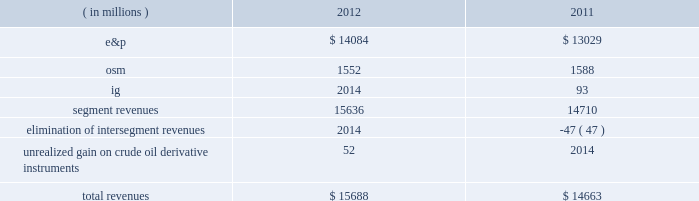Key operating and financial activities significant operating and financial activities during 2012 include : 2022 net proved reserve additions for the e&p and osm segments combined of 389 mmboe , for a 226 percent reserve replacement 2022 increased proved liquid hydrocarbon and synthetic crude oil reserves by 316 mmbbls , for a reserve replacement of 268 percent for these commodities 2022 recorded more than 95 percent average operational availability for operated e&p assets 2022 increased e&p net sales volumes , excluding libya , by 8 percent 2022 eagle ford shale average net sales volumes of 65 mboed for december 2012 , a fourfold increase over december 2011 2022 bakken shale average net sales volumes of 29 mboed , a 71 percent increase over last year 2022 resumed sales from libya and reached pre-conflict production levels 2022 international liquid hydrocarbon sales volumes , for which average realizations have exceeded wti , were 62 percent of net e&p liquid hydrocarbon sales 2022 closed $ 1 billion of acquisitions in the core of the eagle ford shale 2022 assumed operatorship of the vilje field located offshore norway 2022 signed agreements for new exploration positions in e.g. , gabon , kenya and ethiopia 2022 issued $ 1 billion of 3-year senior notes at 0.9 percent interest and $ 1 billion of 10-year senior notes at 2.8 percent interest some significant 2013 activities through february 22 , 2013 include : 2022 closed sale of our alaska assets in january 2013 2022 closed sale of our interest in the neptune gas plant in february 2013 consolidated results of operations : 2012 compared to 2011 consolidated income before income taxes was 38 percent higher in 2012 than consolidated income from continuing operations before income taxes were in 2011 , largely due to higher liquid hydrocarbon sales volumes in our e&p segment , partially offset by lower earnings from our osm and ig segments .
The 7 percent decrease in income from continuing operations included lower earnings in the u.k .
And e.g. , partially offset by higher earnings in libya .
Also , in 2011 we were not in an excess foreign tax credit position for the entire year as we were in 2012 .
The effective income tax rate for continuing operations was 74 percent in 2012 compared to 61 percent in 2011 .
Revenues are summarized in the table: .
E&p segment revenues increased $ 1055 million from 2011 to 2012 , primarily due to higher average liquid hydrocarbon sales volumes .
E&p segment revenues included a net realized gain on crude oil derivative instruments of $ 15 million in 2012 while the impact of derivatives was not significant in 2011 .
See item 8 .
Financial statements and supplementary data 2013 note 16 to the consolidated financial statement for more information about our crude oil derivative instruments .
Included in our e&p segment are supply optimization activities which include the purchase of commodities from third parties for resale .
See the cost of revenues discussion as revenues from supply optimization approximate the related costs .
Supply optimization serves to aggregate volumes in order to satisfy transportation commitments and to achieve flexibility within product .
By how much did total revenue increase from 2011 to 2012? 
Computations: ((15688 - 14663) / 14663)
Answer: 0.0699. 